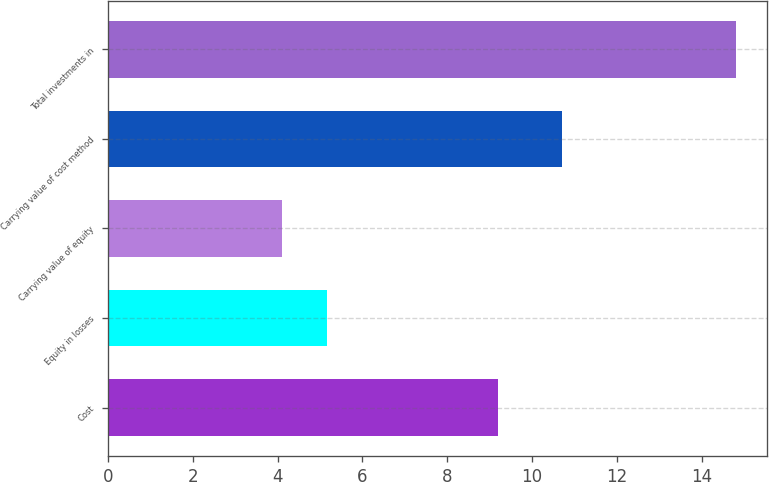Convert chart to OTSL. <chart><loc_0><loc_0><loc_500><loc_500><bar_chart><fcel>Cost<fcel>Equity in losses<fcel>Carrying value of equity<fcel>Carrying value of cost method<fcel>Total investments in<nl><fcel>9.2<fcel>5.17<fcel>4.1<fcel>10.7<fcel>14.8<nl></chart> 